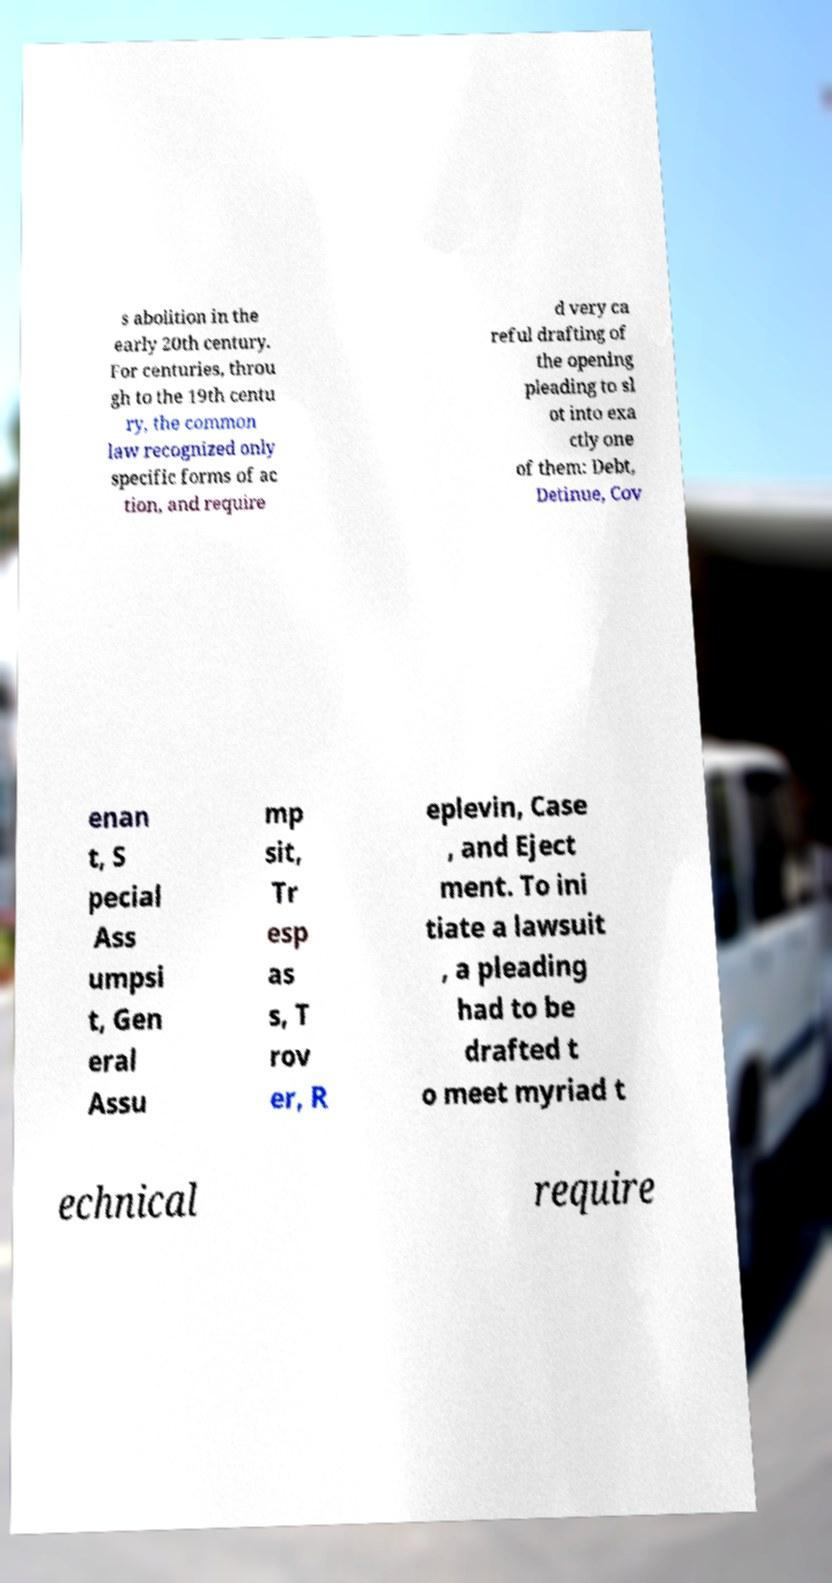Please identify and transcribe the text found in this image. s abolition in the early 20th century. For centuries, throu gh to the 19th centu ry, the common law recognized only specific forms of ac tion, and require d very ca reful drafting of the opening pleading to sl ot into exa ctly one of them: Debt, Detinue, Cov enan t, S pecial Ass umpsi t, Gen eral Assu mp sit, Tr esp as s, T rov er, R eplevin, Case , and Eject ment. To ini tiate a lawsuit , a pleading had to be drafted t o meet myriad t echnical require 